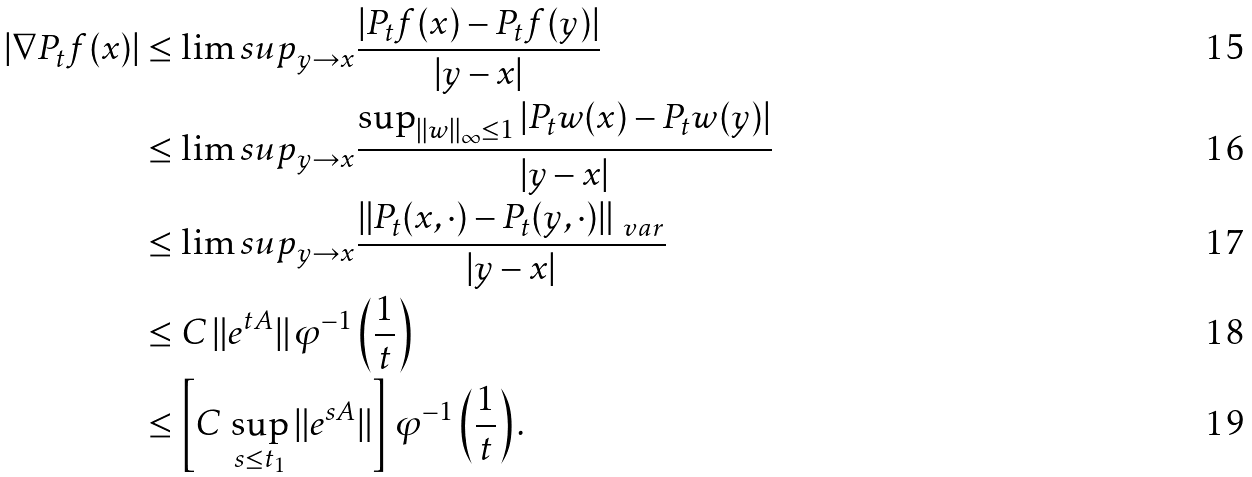<formula> <loc_0><loc_0><loc_500><loc_500>| \nabla P _ { t } f ( x ) | & \leq \lim s u p _ { y \to x } \frac { | P _ { t } f ( x ) - P _ { t } f ( y ) | } { | y - x | } \\ & \leq \lim s u p _ { y \to x } \frac { \sup _ { \| w \| _ { \infty } \leq 1 } | P _ { t } w ( x ) - P _ { t } w ( y ) | } { | y - x | } \\ & \leq \lim s u p _ { y \to x } \frac { \| P _ { t } ( x , \cdot ) - P _ { t } ( y , \cdot ) \| _ { \ v a r } } { | y - x | } \\ & \leq C \, \| e ^ { t A } \| \, \varphi ^ { - 1 } \left ( \frac { 1 } { t } \right ) \\ & \leq \left [ C \, \sup _ { s \leq t _ { 1 } } \| e ^ { s A } \| \right ] \, \varphi ^ { - 1 } \left ( \frac { 1 } { t } \right ) .</formula> 